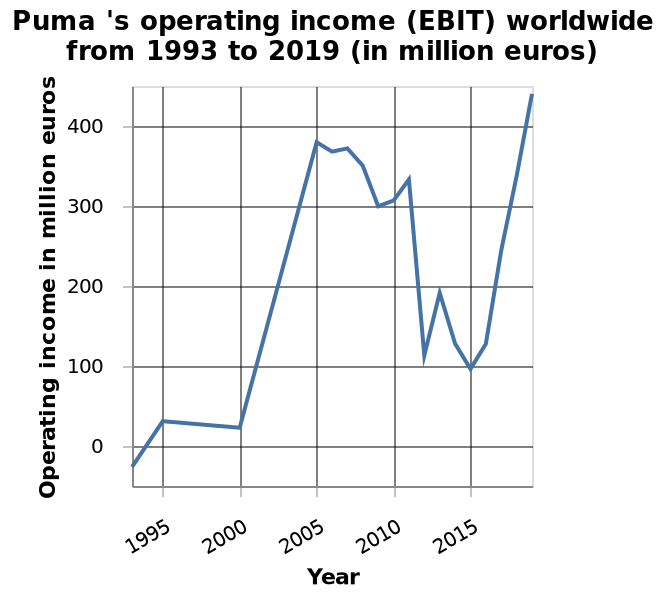<image>
Offer a thorough analysis of the image. There are a lot of fluctuations on this graph. From 1993 to 2017 the operating income has grown from 0 to over 400 million euros. However there is a steep rise in 2000 -2005 from approx 20 million to 380 million euros and a steeper drop 2011-2012 from 340 to 100 million euros. The income then recovers in 2013 to 200 million drops again in 2015 before becoming 400 million in 2019. What is the maximum year represented on the x-axis? The maximum year represented on the x-axis is 2015. What was the operating income in 1993?   The operating income in 1993 was 0 million euros. 